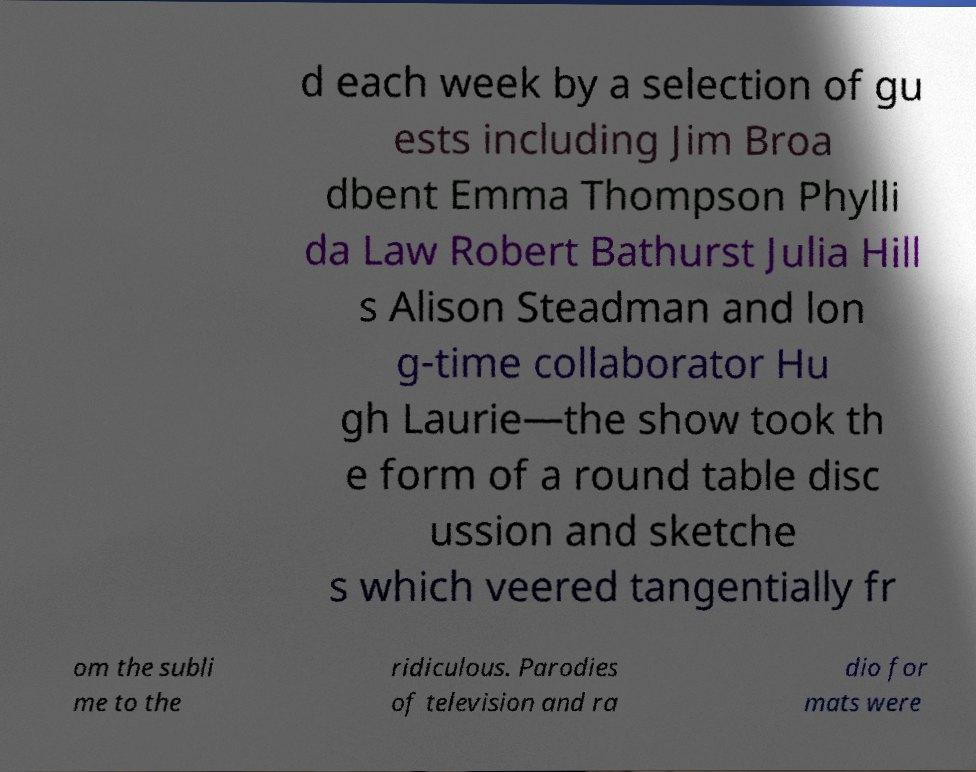Please identify and transcribe the text found in this image. d each week by a selection of gu ests including Jim Broa dbent Emma Thompson Phylli da Law Robert Bathurst Julia Hill s Alison Steadman and lon g-time collaborator Hu gh Laurie—the show took th e form of a round table disc ussion and sketche s which veered tangentially fr om the subli me to the ridiculous. Parodies of television and ra dio for mats were 